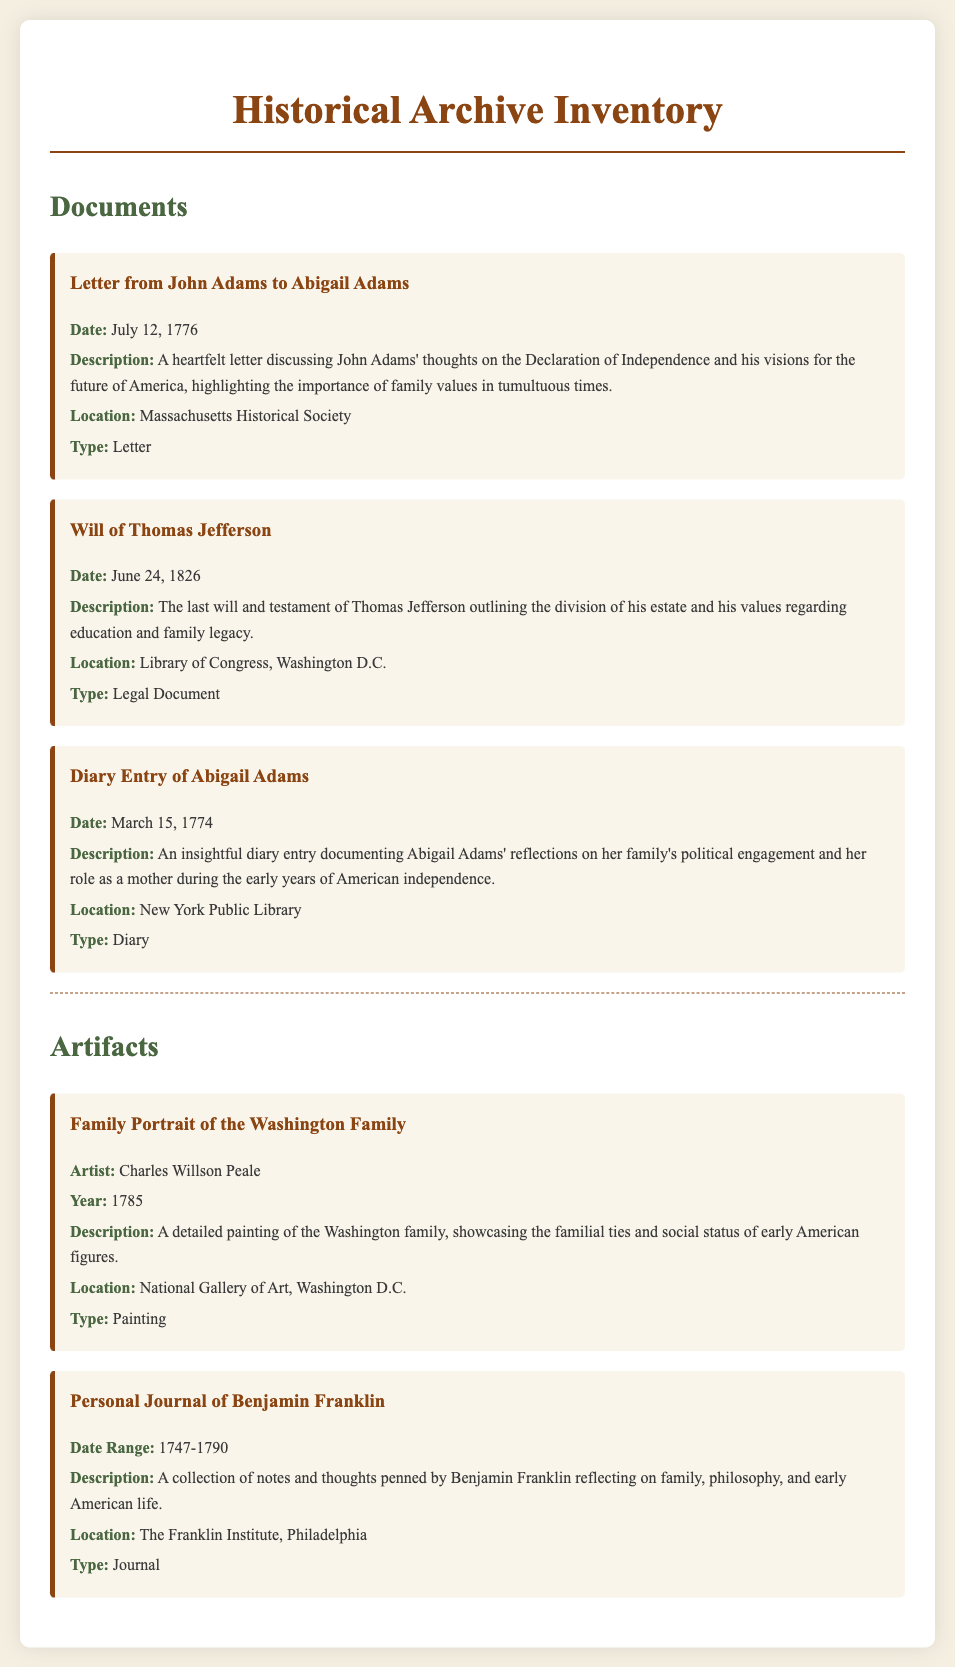What is the date of the letter from John Adams? The letter from John Adams is dated July 12, 1776.
Answer: July 12, 1776 Who wrote the will mentioned in the document? The will mentioned is attributed to Thomas Jefferson.
Answer: Thomas Jefferson What type of document is Abigail Adams' diary entry? Abigail Adams' diary entry is categorized as a Diary.
Answer: Diary Which family is depicted in the painting by Charles Willson Peale? The painting depicts the Washington family.
Answer: Washington family What is the location of the personal journal of Benjamin Franklin? The personal journal of Benjamin Franklin is located at The Franklin Institute, Philadelphia.
Answer: The Franklin Institute, Philadelphia What year was the Family Portrait of the Washington Family created? The Family Portrait was created in the year 1785.
Answer: 1785 What did John Adams discuss in his letter to Abigail Adams? John Adams discussed his thoughts on the Declaration of Independence and family values.
Answer: Thoughts on the Declaration of Independence and family values What significance does the document link to Thomas Jefferson? The document links Thomas Jefferson to the division of his estate and family legacy.
Answer: Division of his estate and family legacy What is the specific type of the legal document related to Thomas Jefferson? The legal document related to Thomas Jefferson is a Will.
Answer: Will 